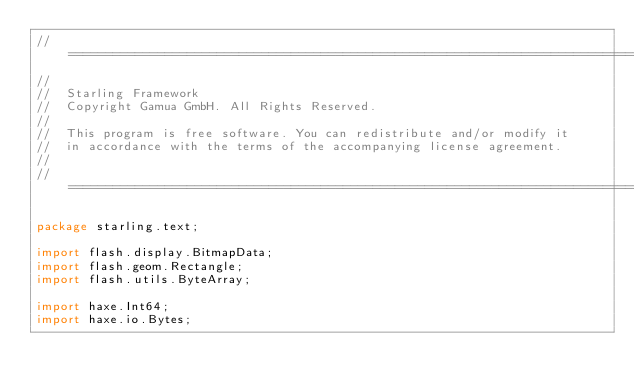<code> <loc_0><loc_0><loc_500><loc_500><_Haxe_>// =================================================================================================
//
//	Starling Framework
//	Copyright Gamua GmbH. All Rights Reserved.
//
//	This program is free software. You can redistribute and/or modify it
//	in accordance with the terms of the accompanying license agreement.
//
// =================================================================================================

package starling.text;

import flash.display.BitmapData;
import flash.geom.Rectangle;
import flash.utils.ByteArray;

import haxe.Int64;
import haxe.io.Bytes;</code> 